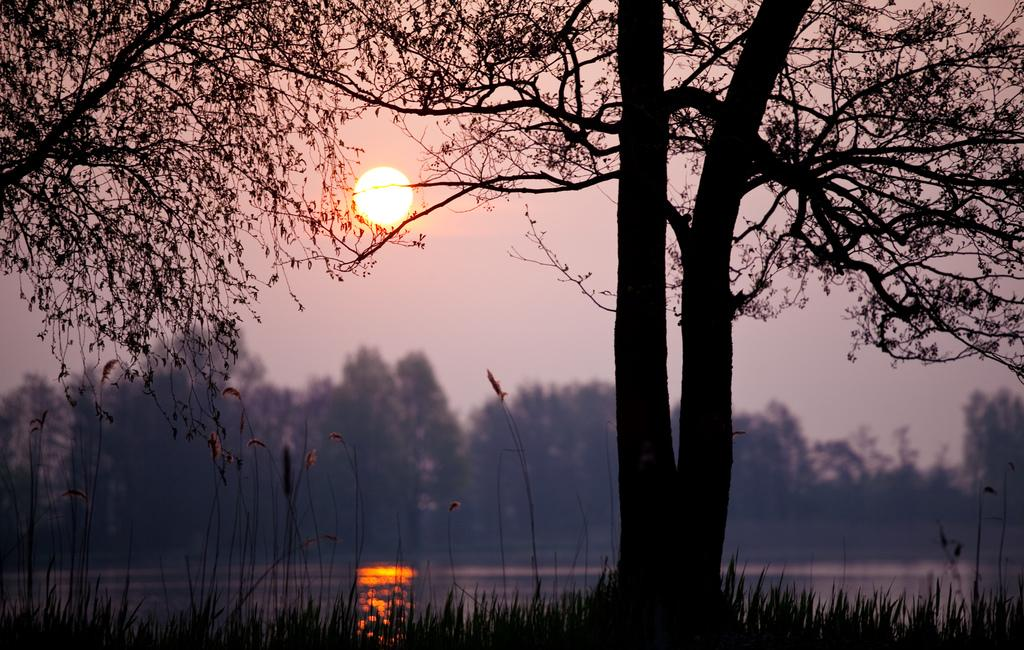What is the main subject in the middle of the image? There is a tree in the middle of the image. What time of day is depicted in the image? The image depicts a sunset. What type of vegetation is present at the bottom of the image? Grass is present at the bottom of the image. What else can be seen at the bottom of the image besides grass? Water is visible at the bottom of the image. What is present at the top of the image? The sky is present at the top of the image. How many giants are visible in the image? There are no giants present in the image. What shape is the window in the image? There is no window present in the image. 